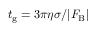Convert formula to latex. <formula><loc_0><loc_0><loc_500><loc_500>t _ { g } = 3 \pi \eta \sigma / | F _ { B } |</formula> 